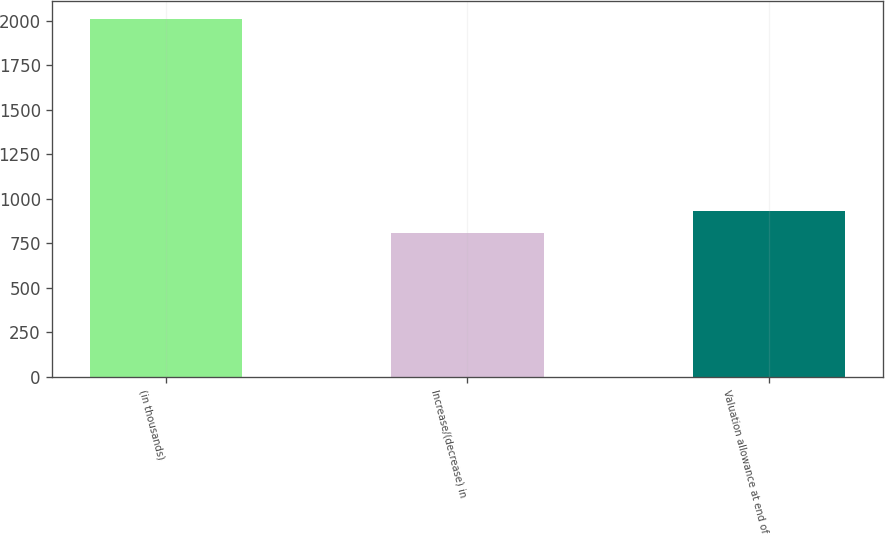Convert chart to OTSL. <chart><loc_0><loc_0><loc_500><loc_500><bar_chart><fcel>(in thousands)<fcel>Increase/(decrease) in<fcel>Valuation allowance at end of<nl><fcel>2010<fcel>810<fcel>930<nl></chart> 